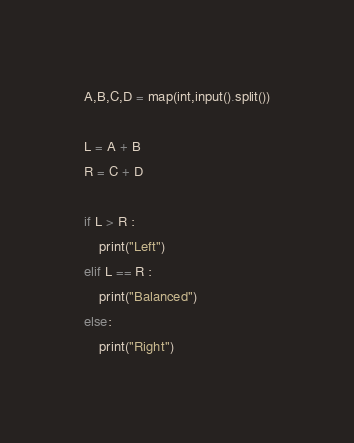<code> <loc_0><loc_0><loc_500><loc_500><_Python_>A,B,C,D = map(int,input().split())

L = A + B
R = C + D

if L > R :
    print("Left")
elif L == R :
    print("Balanced")
else:
    print("Right")

</code> 